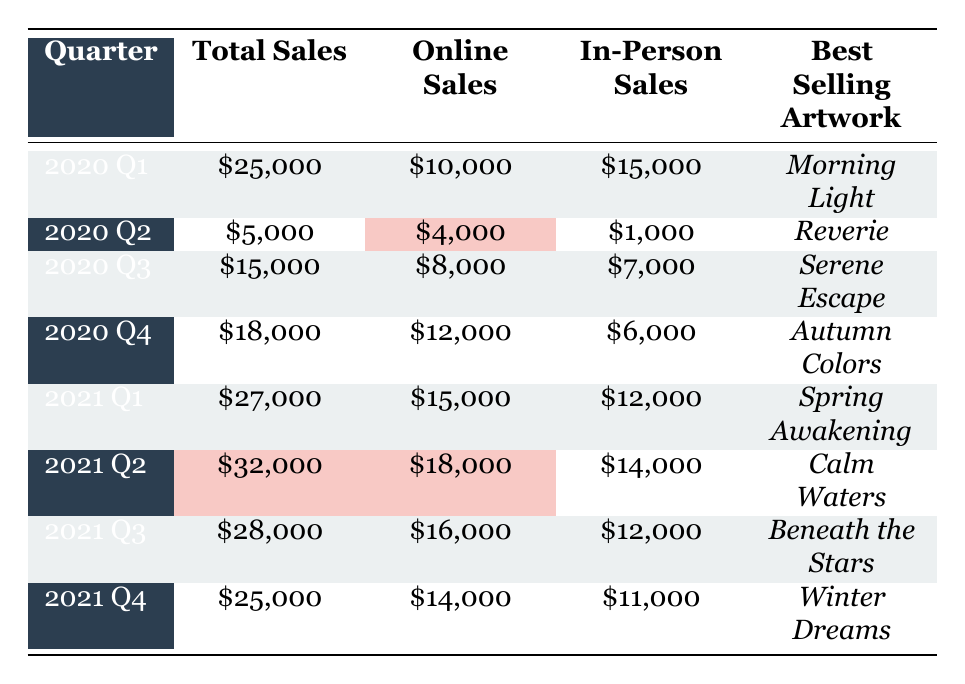What were the total sales for Q2 of 2020? The table shows that for the quarter of Q2 in 2020, the total sales were $5,000.
Answer: $5,000 What was the best selling artwork in Q1 of 2021? According to the table, the best selling artwork in Q1 of 2021 was "Spring Awakening" by Grace Lee.
Answer: Spring Awakening What is the difference between online sales and in-person sales for Q3 2020? In Q3 2020, online sales were $8,000 and in-person sales were $7,000. The difference is $8,000 - $7,000 = $1,000.
Answer: $1,000 Which quarter had the highest total sales, and what was the amount? The table indicates that Q2 of 2021 had the highest total sales at $32,000.
Answer: Q2 2021, $32,000 What were the online sales for Q4 2021, and how did they compare to in-person sales for the same quarter? The table shows that online sales for Q4 2021 were $14,000, while in-person sales were $11,000. Online sales were higher by $14,000 - $11,000 = $3,000.
Answer: $14,000, online sales were $3,000 higher Is the best selling artist for Q1 2021 the same as for Q1 2020? The best selling artist for Q1 2021 is Cooper Allen, while for Q1 2020 it's James Caldwell. Therefore, they are not the same.
Answer: No What was the total sales increase from Q2 2020 to Q2 2021? In Q2 2020, total sales were $5,000 and in Q2 2021, it was $32,000. The increase is $32,000 - $5,000 = $27,000.
Answer: $27,000 Which quarter had the lowest online sales and what was the amount? The table shows that Q2 2020 had the lowest online sales amounting to $4,000.
Answer: Q2 2020, $4,000 What percentage of the total sales for Q3 2021 came from online sales? In Q3 2021, total sales were $28,000 and online sales were $16,000. The percentage is ($16,000 / $28,000) * 100 = 57.14%.
Answer: 57.14% If we look at the best selling artworks, how many different artworks were sold as best sellers across all quarters? Reviewing the table, there are 8 different best selling artworks for each quarter: "Morning Light," "Reverie," "Serene Escape," "Autumn Colors," "Spring Awakening," "Calm Waters," "Beneath the Stars," and "Winter Dreams." So 8 different artworks.
Answer: 8 How much were the in-person sales for Q4 2020 compared to Q4 2021? The in-person sales for Q4 2020 were $6,000 and for Q4 2021, they were $11,000. The difference is $11,000 - $6,000 = $5,000 more in Q4 2021.
Answer: $5,000 more in Q4 2021 